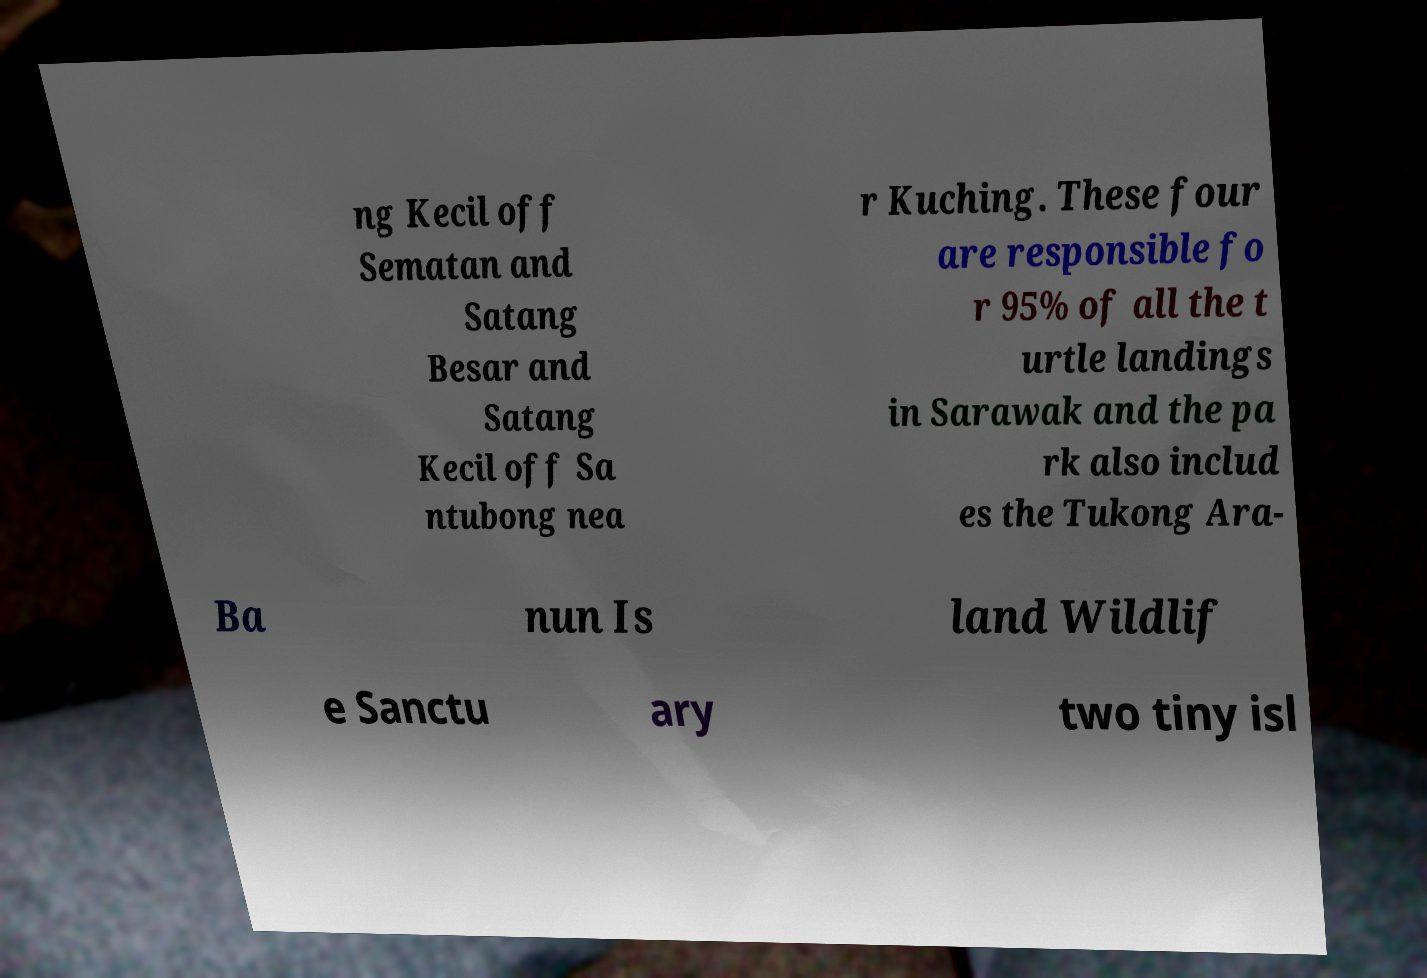Please read and relay the text visible in this image. What does it say? ng Kecil off Sematan and Satang Besar and Satang Kecil off Sa ntubong nea r Kuching. These four are responsible fo r 95% of all the t urtle landings in Sarawak and the pa rk also includ es the Tukong Ara- Ba nun Is land Wildlif e Sanctu ary two tiny isl 